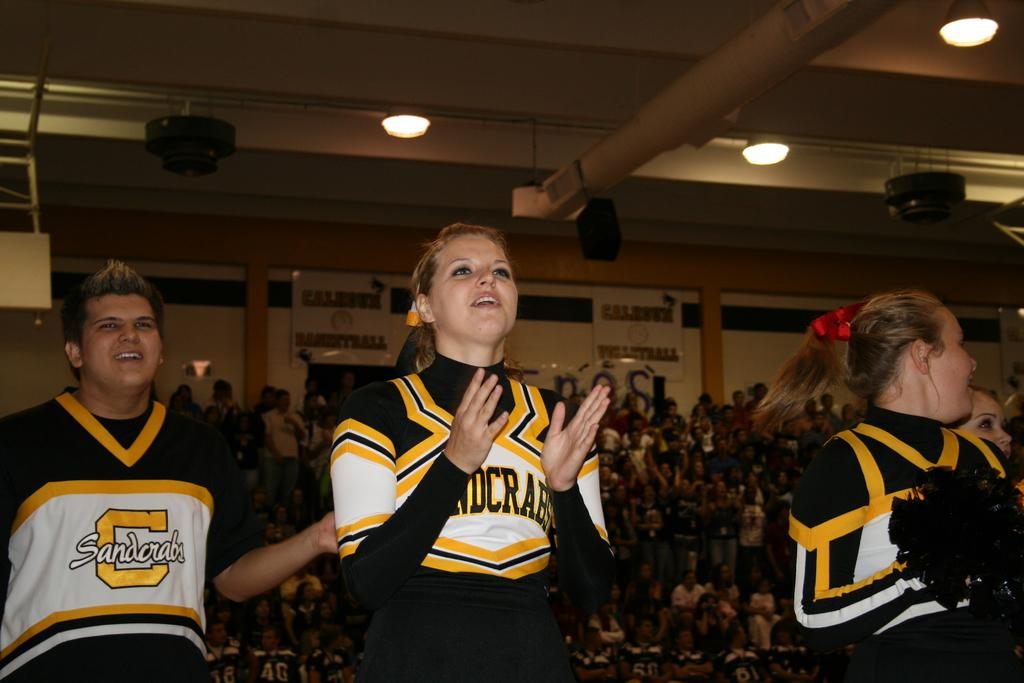Provide a one-sentence caption for the provided image. Members of the Sandcrabs cheer team get the fans fired up!. 